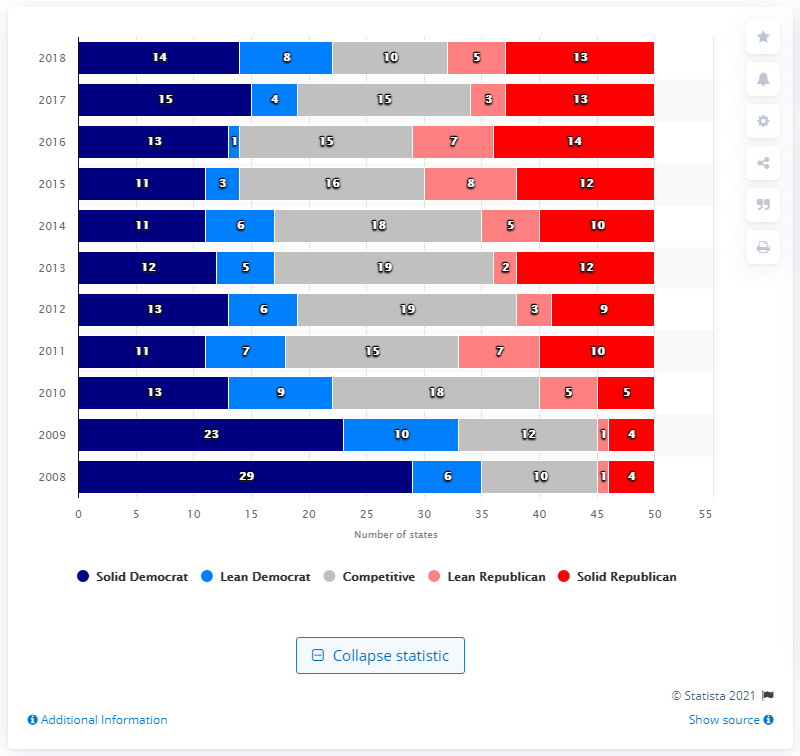List a handful of essential elements in this visual. In 2016, 14 states identified with or leaned towards the Democratic Party. 